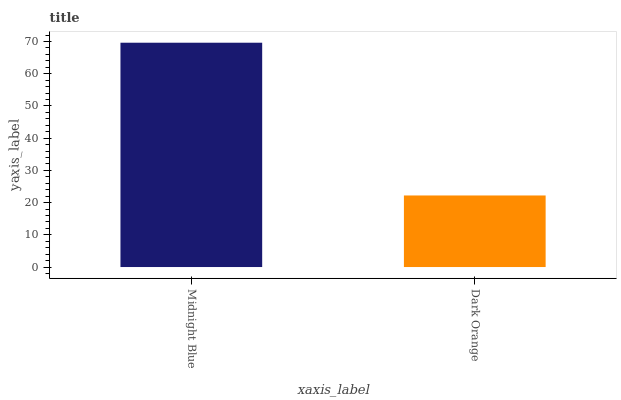Is Dark Orange the minimum?
Answer yes or no. Yes. Is Midnight Blue the maximum?
Answer yes or no. Yes. Is Dark Orange the maximum?
Answer yes or no. No. Is Midnight Blue greater than Dark Orange?
Answer yes or no. Yes. Is Dark Orange less than Midnight Blue?
Answer yes or no. Yes. Is Dark Orange greater than Midnight Blue?
Answer yes or no. No. Is Midnight Blue less than Dark Orange?
Answer yes or no. No. Is Midnight Blue the high median?
Answer yes or no. Yes. Is Dark Orange the low median?
Answer yes or no. Yes. Is Dark Orange the high median?
Answer yes or no. No. Is Midnight Blue the low median?
Answer yes or no. No. 